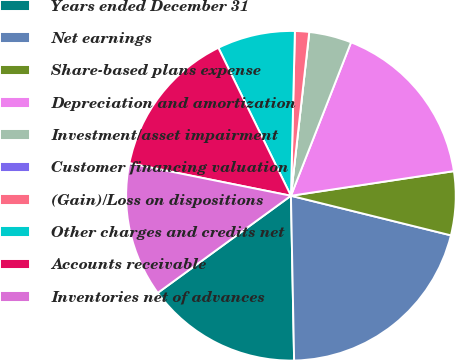Convert chart to OTSL. <chart><loc_0><loc_0><loc_500><loc_500><pie_chart><fcel>Years ended December 31<fcel>Net earnings<fcel>Share-based plans expense<fcel>Depreciation and amortization<fcel>Investment/asset impairment<fcel>Customer financing valuation<fcel>(Gain)/Loss on dispositions<fcel>Other charges and credits net<fcel>Accounts receivable<fcel>Inventories net of advances<nl><fcel>15.28%<fcel>20.83%<fcel>6.25%<fcel>16.67%<fcel>4.17%<fcel>0.0%<fcel>1.39%<fcel>7.64%<fcel>14.58%<fcel>13.19%<nl></chart> 